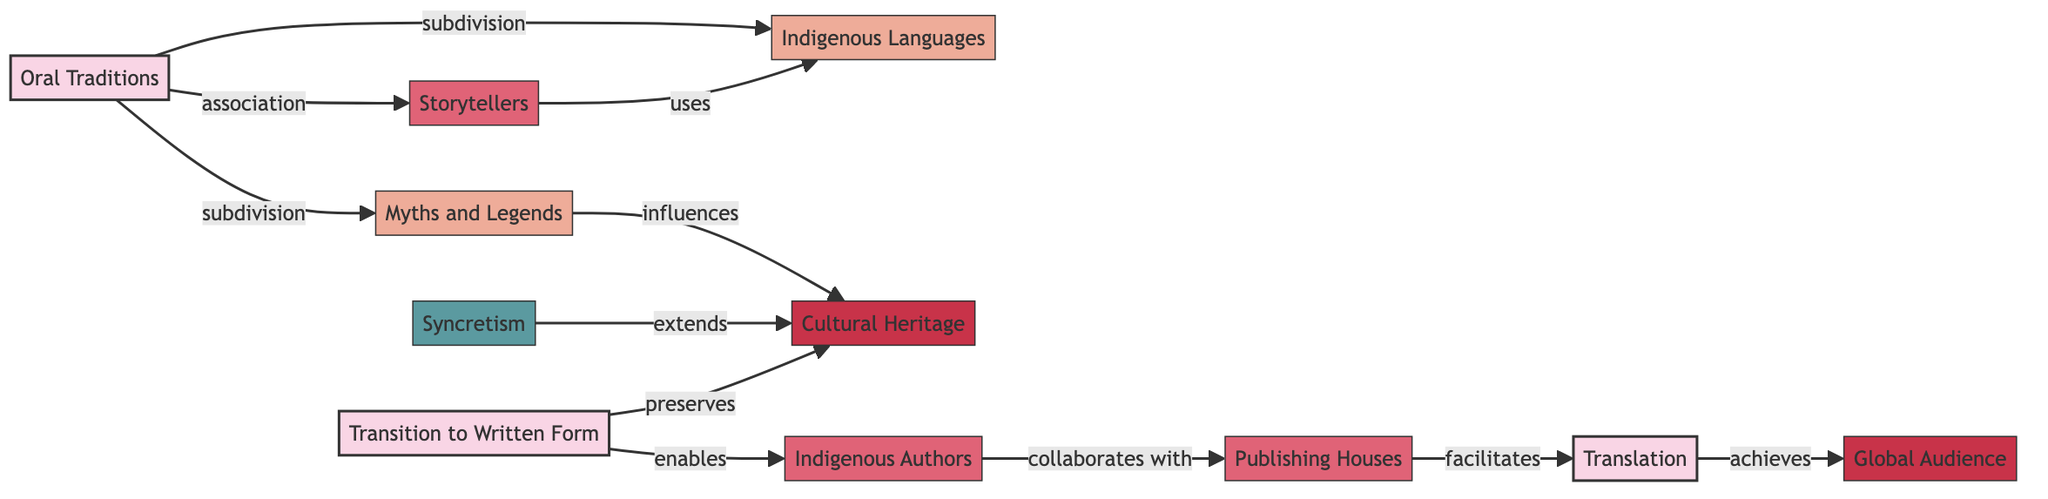What nodes does "Oral Traditions" connect to? "Oral Traditions" connects to "Myths and Legends," "Indigenous Languages," and "Storytellers." These connections are shown as subdivisions and associations in the diagram.
Answer: Myths and Legends, Indigenous Languages, Storytellers How many edges are in the diagram? Counting all the connections, we find there are 10 edges represented, each depicting different relationships between nodes.
Answer: 10 What type of impact does "Cultural Heritage" have on "Myths and Legends"? The diagram shows that "Myths and Legends" influences "Cultural Heritage," indicating a relationship of importance in preserving and shaping cultural narratives.
Answer: influences Which node is facilitated by "Publishing Houses"? The diagram indicates that "Translation" is facilitated by "Publishing Houses," showing their role in making works accessible to broader audiences.
Answer: Translation How does "Transition to Written Form" relate to "Cultural Heritage"? "Transition to Written Form" preserves "Cultural Heritage," suggesting that the act of writing down narratives can help maintain cultural traditions and knowledge.
Answer: preserves What is the relationship between "Indigenous Authors" and "Publishing Houses"? "Indigenous Authors" collaborates with "Publishing Houses," showing that there is a partnership in bringing indigenous narratives into published formats.
Answer: collaborates with What is the final impact achieved through "Translation"? The connection shows that "Translation" achieves a "Global Audience," highlighting the significance of translation in reaching wider readerships beyond local cultures.
Answer: Global Audience Which type of node is "Syncretism"? In the diagram, "Syncretism" is classified as an element, indicating it plays a specific role or function in the context of the other nodes.
Answer: element 